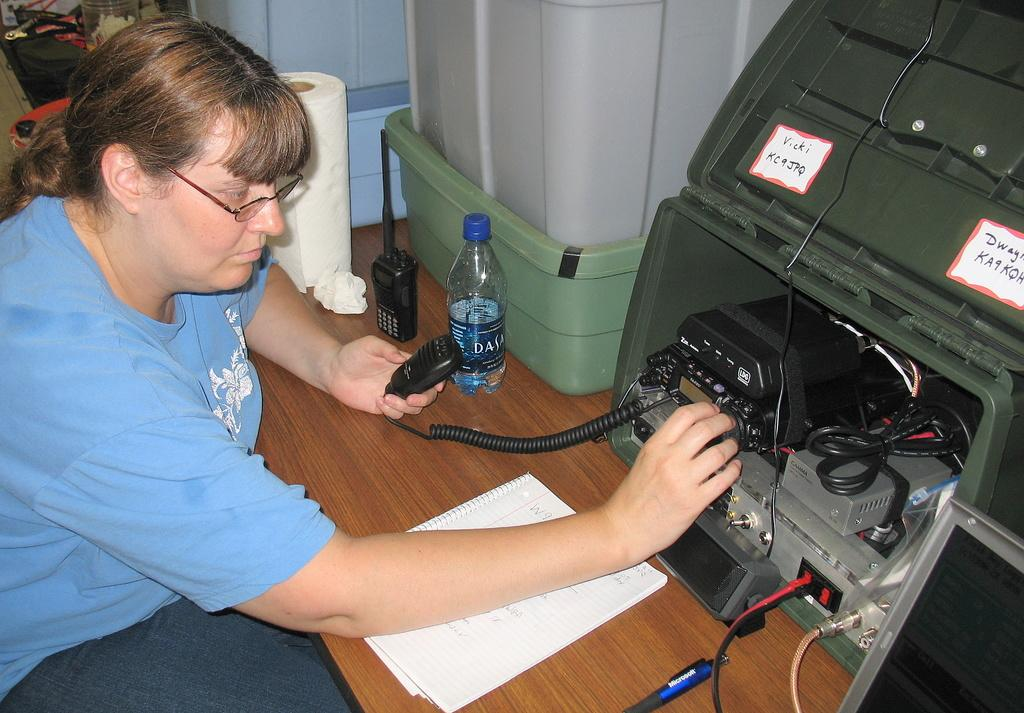<image>
Share a concise interpretation of the image provided. The machine has the handwritten name of Vicki on it. 